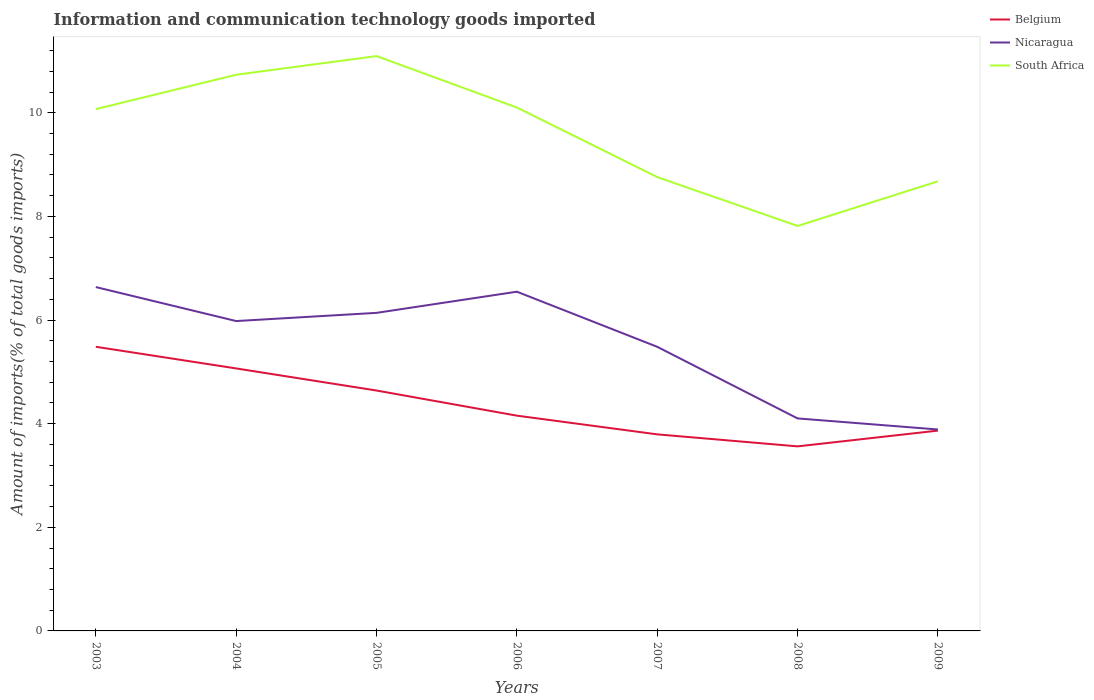How many different coloured lines are there?
Give a very brief answer. 3. Does the line corresponding to South Africa intersect with the line corresponding to Belgium?
Offer a terse response. No. Is the number of lines equal to the number of legend labels?
Keep it short and to the point. Yes. Across all years, what is the maximum amount of goods imported in Belgium?
Offer a very short reply. 3.56. What is the total amount of goods imported in Belgium in the graph?
Your answer should be very brief. 0.49. What is the difference between the highest and the second highest amount of goods imported in Belgium?
Give a very brief answer. 1.92. What is the difference between the highest and the lowest amount of goods imported in Nicaragua?
Make the answer very short. 4. Is the amount of goods imported in Belgium strictly greater than the amount of goods imported in South Africa over the years?
Give a very brief answer. Yes. How many years are there in the graph?
Your answer should be compact. 7. What is the difference between two consecutive major ticks on the Y-axis?
Provide a short and direct response. 2. Does the graph contain any zero values?
Offer a very short reply. No. Where does the legend appear in the graph?
Provide a succinct answer. Top right. How are the legend labels stacked?
Offer a terse response. Vertical. What is the title of the graph?
Keep it short and to the point. Information and communication technology goods imported. What is the label or title of the Y-axis?
Provide a succinct answer. Amount of imports(% of total goods imports). What is the Amount of imports(% of total goods imports) of Belgium in 2003?
Provide a succinct answer. 5.48. What is the Amount of imports(% of total goods imports) of Nicaragua in 2003?
Provide a succinct answer. 6.64. What is the Amount of imports(% of total goods imports) of South Africa in 2003?
Give a very brief answer. 10.07. What is the Amount of imports(% of total goods imports) of Belgium in 2004?
Your answer should be very brief. 5.07. What is the Amount of imports(% of total goods imports) of Nicaragua in 2004?
Provide a short and direct response. 5.98. What is the Amount of imports(% of total goods imports) in South Africa in 2004?
Offer a terse response. 10.73. What is the Amount of imports(% of total goods imports) of Belgium in 2005?
Offer a very short reply. 4.64. What is the Amount of imports(% of total goods imports) in Nicaragua in 2005?
Your answer should be very brief. 6.14. What is the Amount of imports(% of total goods imports) of South Africa in 2005?
Provide a succinct answer. 11.09. What is the Amount of imports(% of total goods imports) of Belgium in 2006?
Give a very brief answer. 4.15. What is the Amount of imports(% of total goods imports) in Nicaragua in 2006?
Ensure brevity in your answer.  6.55. What is the Amount of imports(% of total goods imports) of South Africa in 2006?
Keep it short and to the point. 10.1. What is the Amount of imports(% of total goods imports) of Belgium in 2007?
Ensure brevity in your answer.  3.79. What is the Amount of imports(% of total goods imports) in Nicaragua in 2007?
Give a very brief answer. 5.48. What is the Amount of imports(% of total goods imports) of South Africa in 2007?
Your answer should be compact. 8.76. What is the Amount of imports(% of total goods imports) of Belgium in 2008?
Provide a short and direct response. 3.56. What is the Amount of imports(% of total goods imports) in Nicaragua in 2008?
Keep it short and to the point. 4.1. What is the Amount of imports(% of total goods imports) in South Africa in 2008?
Your answer should be very brief. 7.82. What is the Amount of imports(% of total goods imports) of Belgium in 2009?
Provide a short and direct response. 3.87. What is the Amount of imports(% of total goods imports) in Nicaragua in 2009?
Provide a succinct answer. 3.89. What is the Amount of imports(% of total goods imports) of South Africa in 2009?
Make the answer very short. 8.68. Across all years, what is the maximum Amount of imports(% of total goods imports) in Belgium?
Give a very brief answer. 5.48. Across all years, what is the maximum Amount of imports(% of total goods imports) in Nicaragua?
Offer a terse response. 6.64. Across all years, what is the maximum Amount of imports(% of total goods imports) in South Africa?
Your response must be concise. 11.09. Across all years, what is the minimum Amount of imports(% of total goods imports) in Belgium?
Your response must be concise. 3.56. Across all years, what is the minimum Amount of imports(% of total goods imports) in Nicaragua?
Ensure brevity in your answer.  3.89. Across all years, what is the minimum Amount of imports(% of total goods imports) of South Africa?
Provide a succinct answer. 7.82. What is the total Amount of imports(% of total goods imports) of Belgium in the graph?
Provide a short and direct response. 30.56. What is the total Amount of imports(% of total goods imports) in Nicaragua in the graph?
Offer a terse response. 38.77. What is the total Amount of imports(% of total goods imports) of South Africa in the graph?
Offer a very short reply. 67.25. What is the difference between the Amount of imports(% of total goods imports) in Belgium in 2003 and that in 2004?
Provide a short and direct response. 0.42. What is the difference between the Amount of imports(% of total goods imports) in Nicaragua in 2003 and that in 2004?
Make the answer very short. 0.66. What is the difference between the Amount of imports(% of total goods imports) of South Africa in 2003 and that in 2004?
Provide a succinct answer. -0.66. What is the difference between the Amount of imports(% of total goods imports) in Belgium in 2003 and that in 2005?
Give a very brief answer. 0.84. What is the difference between the Amount of imports(% of total goods imports) in Nicaragua in 2003 and that in 2005?
Your response must be concise. 0.5. What is the difference between the Amount of imports(% of total goods imports) in South Africa in 2003 and that in 2005?
Your answer should be compact. -1.02. What is the difference between the Amount of imports(% of total goods imports) in Belgium in 2003 and that in 2006?
Ensure brevity in your answer.  1.33. What is the difference between the Amount of imports(% of total goods imports) of Nicaragua in 2003 and that in 2006?
Provide a short and direct response. 0.09. What is the difference between the Amount of imports(% of total goods imports) in South Africa in 2003 and that in 2006?
Offer a very short reply. -0.03. What is the difference between the Amount of imports(% of total goods imports) in Belgium in 2003 and that in 2007?
Offer a very short reply. 1.69. What is the difference between the Amount of imports(% of total goods imports) in Nicaragua in 2003 and that in 2007?
Your answer should be very brief. 1.15. What is the difference between the Amount of imports(% of total goods imports) of South Africa in 2003 and that in 2007?
Your response must be concise. 1.31. What is the difference between the Amount of imports(% of total goods imports) in Belgium in 2003 and that in 2008?
Your answer should be compact. 1.92. What is the difference between the Amount of imports(% of total goods imports) in Nicaragua in 2003 and that in 2008?
Your answer should be compact. 2.53. What is the difference between the Amount of imports(% of total goods imports) of South Africa in 2003 and that in 2008?
Your answer should be compact. 2.26. What is the difference between the Amount of imports(% of total goods imports) of Belgium in 2003 and that in 2009?
Ensure brevity in your answer.  1.62. What is the difference between the Amount of imports(% of total goods imports) in Nicaragua in 2003 and that in 2009?
Make the answer very short. 2.75. What is the difference between the Amount of imports(% of total goods imports) in South Africa in 2003 and that in 2009?
Offer a terse response. 1.39. What is the difference between the Amount of imports(% of total goods imports) of Belgium in 2004 and that in 2005?
Your answer should be compact. 0.43. What is the difference between the Amount of imports(% of total goods imports) in Nicaragua in 2004 and that in 2005?
Ensure brevity in your answer.  -0.16. What is the difference between the Amount of imports(% of total goods imports) in South Africa in 2004 and that in 2005?
Provide a succinct answer. -0.36. What is the difference between the Amount of imports(% of total goods imports) of Belgium in 2004 and that in 2006?
Keep it short and to the point. 0.91. What is the difference between the Amount of imports(% of total goods imports) in Nicaragua in 2004 and that in 2006?
Offer a terse response. -0.57. What is the difference between the Amount of imports(% of total goods imports) of South Africa in 2004 and that in 2006?
Give a very brief answer. 0.63. What is the difference between the Amount of imports(% of total goods imports) in Belgium in 2004 and that in 2007?
Keep it short and to the point. 1.27. What is the difference between the Amount of imports(% of total goods imports) of Nicaragua in 2004 and that in 2007?
Offer a terse response. 0.5. What is the difference between the Amount of imports(% of total goods imports) of South Africa in 2004 and that in 2007?
Ensure brevity in your answer.  1.98. What is the difference between the Amount of imports(% of total goods imports) of Belgium in 2004 and that in 2008?
Your answer should be compact. 1.5. What is the difference between the Amount of imports(% of total goods imports) of Nicaragua in 2004 and that in 2008?
Keep it short and to the point. 1.88. What is the difference between the Amount of imports(% of total goods imports) of South Africa in 2004 and that in 2008?
Ensure brevity in your answer.  2.92. What is the difference between the Amount of imports(% of total goods imports) in Belgium in 2004 and that in 2009?
Your answer should be compact. 1.2. What is the difference between the Amount of imports(% of total goods imports) in Nicaragua in 2004 and that in 2009?
Your response must be concise. 2.09. What is the difference between the Amount of imports(% of total goods imports) in South Africa in 2004 and that in 2009?
Offer a very short reply. 2.06. What is the difference between the Amount of imports(% of total goods imports) of Belgium in 2005 and that in 2006?
Provide a succinct answer. 0.48. What is the difference between the Amount of imports(% of total goods imports) in Nicaragua in 2005 and that in 2006?
Make the answer very short. -0.41. What is the difference between the Amount of imports(% of total goods imports) of South Africa in 2005 and that in 2006?
Provide a short and direct response. 0.99. What is the difference between the Amount of imports(% of total goods imports) in Belgium in 2005 and that in 2007?
Your answer should be very brief. 0.85. What is the difference between the Amount of imports(% of total goods imports) of Nicaragua in 2005 and that in 2007?
Keep it short and to the point. 0.66. What is the difference between the Amount of imports(% of total goods imports) of South Africa in 2005 and that in 2007?
Your response must be concise. 2.34. What is the difference between the Amount of imports(% of total goods imports) in Belgium in 2005 and that in 2008?
Your answer should be very brief. 1.08. What is the difference between the Amount of imports(% of total goods imports) in Nicaragua in 2005 and that in 2008?
Give a very brief answer. 2.04. What is the difference between the Amount of imports(% of total goods imports) in South Africa in 2005 and that in 2008?
Your answer should be compact. 3.28. What is the difference between the Amount of imports(% of total goods imports) in Belgium in 2005 and that in 2009?
Provide a short and direct response. 0.77. What is the difference between the Amount of imports(% of total goods imports) in Nicaragua in 2005 and that in 2009?
Give a very brief answer. 2.25. What is the difference between the Amount of imports(% of total goods imports) in South Africa in 2005 and that in 2009?
Keep it short and to the point. 2.42. What is the difference between the Amount of imports(% of total goods imports) of Belgium in 2006 and that in 2007?
Offer a very short reply. 0.36. What is the difference between the Amount of imports(% of total goods imports) of Nicaragua in 2006 and that in 2007?
Offer a very short reply. 1.06. What is the difference between the Amount of imports(% of total goods imports) of South Africa in 2006 and that in 2007?
Keep it short and to the point. 1.34. What is the difference between the Amount of imports(% of total goods imports) in Belgium in 2006 and that in 2008?
Make the answer very short. 0.59. What is the difference between the Amount of imports(% of total goods imports) in Nicaragua in 2006 and that in 2008?
Keep it short and to the point. 2.45. What is the difference between the Amount of imports(% of total goods imports) in South Africa in 2006 and that in 2008?
Give a very brief answer. 2.29. What is the difference between the Amount of imports(% of total goods imports) of Belgium in 2006 and that in 2009?
Give a very brief answer. 0.29. What is the difference between the Amount of imports(% of total goods imports) of Nicaragua in 2006 and that in 2009?
Provide a short and direct response. 2.66. What is the difference between the Amount of imports(% of total goods imports) in South Africa in 2006 and that in 2009?
Provide a short and direct response. 1.42. What is the difference between the Amount of imports(% of total goods imports) of Belgium in 2007 and that in 2008?
Ensure brevity in your answer.  0.23. What is the difference between the Amount of imports(% of total goods imports) of Nicaragua in 2007 and that in 2008?
Offer a very short reply. 1.38. What is the difference between the Amount of imports(% of total goods imports) of South Africa in 2007 and that in 2008?
Give a very brief answer. 0.94. What is the difference between the Amount of imports(% of total goods imports) of Belgium in 2007 and that in 2009?
Provide a succinct answer. -0.07. What is the difference between the Amount of imports(% of total goods imports) of Nicaragua in 2007 and that in 2009?
Give a very brief answer. 1.6. What is the difference between the Amount of imports(% of total goods imports) in South Africa in 2007 and that in 2009?
Give a very brief answer. 0.08. What is the difference between the Amount of imports(% of total goods imports) in Belgium in 2008 and that in 2009?
Offer a very short reply. -0.3. What is the difference between the Amount of imports(% of total goods imports) of Nicaragua in 2008 and that in 2009?
Offer a very short reply. 0.21. What is the difference between the Amount of imports(% of total goods imports) of South Africa in 2008 and that in 2009?
Your response must be concise. -0.86. What is the difference between the Amount of imports(% of total goods imports) of Belgium in 2003 and the Amount of imports(% of total goods imports) of Nicaragua in 2004?
Give a very brief answer. -0.5. What is the difference between the Amount of imports(% of total goods imports) of Belgium in 2003 and the Amount of imports(% of total goods imports) of South Africa in 2004?
Ensure brevity in your answer.  -5.25. What is the difference between the Amount of imports(% of total goods imports) in Nicaragua in 2003 and the Amount of imports(% of total goods imports) in South Africa in 2004?
Your response must be concise. -4.1. What is the difference between the Amount of imports(% of total goods imports) of Belgium in 2003 and the Amount of imports(% of total goods imports) of Nicaragua in 2005?
Offer a terse response. -0.65. What is the difference between the Amount of imports(% of total goods imports) in Belgium in 2003 and the Amount of imports(% of total goods imports) in South Africa in 2005?
Ensure brevity in your answer.  -5.61. What is the difference between the Amount of imports(% of total goods imports) of Nicaragua in 2003 and the Amount of imports(% of total goods imports) of South Africa in 2005?
Keep it short and to the point. -4.46. What is the difference between the Amount of imports(% of total goods imports) in Belgium in 2003 and the Amount of imports(% of total goods imports) in Nicaragua in 2006?
Ensure brevity in your answer.  -1.06. What is the difference between the Amount of imports(% of total goods imports) in Belgium in 2003 and the Amount of imports(% of total goods imports) in South Africa in 2006?
Give a very brief answer. -4.62. What is the difference between the Amount of imports(% of total goods imports) in Nicaragua in 2003 and the Amount of imports(% of total goods imports) in South Africa in 2006?
Keep it short and to the point. -3.46. What is the difference between the Amount of imports(% of total goods imports) in Belgium in 2003 and the Amount of imports(% of total goods imports) in Nicaragua in 2007?
Make the answer very short. 0. What is the difference between the Amount of imports(% of total goods imports) in Belgium in 2003 and the Amount of imports(% of total goods imports) in South Africa in 2007?
Your response must be concise. -3.27. What is the difference between the Amount of imports(% of total goods imports) in Nicaragua in 2003 and the Amount of imports(% of total goods imports) in South Africa in 2007?
Your answer should be very brief. -2.12. What is the difference between the Amount of imports(% of total goods imports) of Belgium in 2003 and the Amount of imports(% of total goods imports) of Nicaragua in 2008?
Provide a succinct answer. 1.38. What is the difference between the Amount of imports(% of total goods imports) of Belgium in 2003 and the Amount of imports(% of total goods imports) of South Africa in 2008?
Keep it short and to the point. -2.33. What is the difference between the Amount of imports(% of total goods imports) in Nicaragua in 2003 and the Amount of imports(% of total goods imports) in South Africa in 2008?
Keep it short and to the point. -1.18. What is the difference between the Amount of imports(% of total goods imports) of Belgium in 2003 and the Amount of imports(% of total goods imports) of Nicaragua in 2009?
Give a very brief answer. 1.6. What is the difference between the Amount of imports(% of total goods imports) of Belgium in 2003 and the Amount of imports(% of total goods imports) of South Africa in 2009?
Your response must be concise. -3.19. What is the difference between the Amount of imports(% of total goods imports) of Nicaragua in 2003 and the Amount of imports(% of total goods imports) of South Africa in 2009?
Provide a succinct answer. -2.04. What is the difference between the Amount of imports(% of total goods imports) of Belgium in 2004 and the Amount of imports(% of total goods imports) of Nicaragua in 2005?
Make the answer very short. -1.07. What is the difference between the Amount of imports(% of total goods imports) of Belgium in 2004 and the Amount of imports(% of total goods imports) of South Africa in 2005?
Your answer should be very brief. -6.03. What is the difference between the Amount of imports(% of total goods imports) of Nicaragua in 2004 and the Amount of imports(% of total goods imports) of South Africa in 2005?
Offer a terse response. -5.11. What is the difference between the Amount of imports(% of total goods imports) in Belgium in 2004 and the Amount of imports(% of total goods imports) in Nicaragua in 2006?
Keep it short and to the point. -1.48. What is the difference between the Amount of imports(% of total goods imports) in Belgium in 2004 and the Amount of imports(% of total goods imports) in South Africa in 2006?
Ensure brevity in your answer.  -5.03. What is the difference between the Amount of imports(% of total goods imports) of Nicaragua in 2004 and the Amount of imports(% of total goods imports) of South Africa in 2006?
Keep it short and to the point. -4.12. What is the difference between the Amount of imports(% of total goods imports) of Belgium in 2004 and the Amount of imports(% of total goods imports) of Nicaragua in 2007?
Give a very brief answer. -0.42. What is the difference between the Amount of imports(% of total goods imports) of Belgium in 2004 and the Amount of imports(% of total goods imports) of South Africa in 2007?
Make the answer very short. -3.69. What is the difference between the Amount of imports(% of total goods imports) in Nicaragua in 2004 and the Amount of imports(% of total goods imports) in South Africa in 2007?
Offer a very short reply. -2.78. What is the difference between the Amount of imports(% of total goods imports) of Belgium in 2004 and the Amount of imports(% of total goods imports) of Nicaragua in 2008?
Your answer should be compact. 0.96. What is the difference between the Amount of imports(% of total goods imports) of Belgium in 2004 and the Amount of imports(% of total goods imports) of South Africa in 2008?
Provide a succinct answer. -2.75. What is the difference between the Amount of imports(% of total goods imports) in Nicaragua in 2004 and the Amount of imports(% of total goods imports) in South Africa in 2008?
Your response must be concise. -1.84. What is the difference between the Amount of imports(% of total goods imports) of Belgium in 2004 and the Amount of imports(% of total goods imports) of Nicaragua in 2009?
Provide a succinct answer. 1.18. What is the difference between the Amount of imports(% of total goods imports) of Belgium in 2004 and the Amount of imports(% of total goods imports) of South Africa in 2009?
Make the answer very short. -3.61. What is the difference between the Amount of imports(% of total goods imports) in Nicaragua in 2004 and the Amount of imports(% of total goods imports) in South Africa in 2009?
Your response must be concise. -2.7. What is the difference between the Amount of imports(% of total goods imports) of Belgium in 2005 and the Amount of imports(% of total goods imports) of Nicaragua in 2006?
Offer a very short reply. -1.91. What is the difference between the Amount of imports(% of total goods imports) in Belgium in 2005 and the Amount of imports(% of total goods imports) in South Africa in 2006?
Keep it short and to the point. -5.46. What is the difference between the Amount of imports(% of total goods imports) of Nicaragua in 2005 and the Amount of imports(% of total goods imports) of South Africa in 2006?
Make the answer very short. -3.96. What is the difference between the Amount of imports(% of total goods imports) of Belgium in 2005 and the Amount of imports(% of total goods imports) of Nicaragua in 2007?
Keep it short and to the point. -0.84. What is the difference between the Amount of imports(% of total goods imports) in Belgium in 2005 and the Amount of imports(% of total goods imports) in South Africa in 2007?
Keep it short and to the point. -4.12. What is the difference between the Amount of imports(% of total goods imports) of Nicaragua in 2005 and the Amount of imports(% of total goods imports) of South Africa in 2007?
Your answer should be compact. -2.62. What is the difference between the Amount of imports(% of total goods imports) in Belgium in 2005 and the Amount of imports(% of total goods imports) in Nicaragua in 2008?
Your answer should be very brief. 0.54. What is the difference between the Amount of imports(% of total goods imports) in Belgium in 2005 and the Amount of imports(% of total goods imports) in South Africa in 2008?
Your response must be concise. -3.18. What is the difference between the Amount of imports(% of total goods imports) in Nicaragua in 2005 and the Amount of imports(% of total goods imports) in South Africa in 2008?
Provide a succinct answer. -1.68. What is the difference between the Amount of imports(% of total goods imports) in Belgium in 2005 and the Amount of imports(% of total goods imports) in Nicaragua in 2009?
Keep it short and to the point. 0.75. What is the difference between the Amount of imports(% of total goods imports) of Belgium in 2005 and the Amount of imports(% of total goods imports) of South Africa in 2009?
Provide a succinct answer. -4.04. What is the difference between the Amount of imports(% of total goods imports) in Nicaragua in 2005 and the Amount of imports(% of total goods imports) in South Africa in 2009?
Your answer should be very brief. -2.54. What is the difference between the Amount of imports(% of total goods imports) in Belgium in 2006 and the Amount of imports(% of total goods imports) in Nicaragua in 2007?
Offer a very short reply. -1.33. What is the difference between the Amount of imports(% of total goods imports) of Belgium in 2006 and the Amount of imports(% of total goods imports) of South Africa in 2007?
Provide a succinct answer. -4.6. What is the difference between the Amount of imports(% of total goods imports) in Nicaragua in 2006 and the Amount of imports(% of total goods imports) in South Africa in 2007?
Keep it short and to the point. -2.21. What is the difference between the Amount of imports(% of total goods imports) in Belgium in 2006 and the Amount of imports(% of total goods imports) in Nicaragua in 2008?
Your answer should be very brief. 0.05. What is the difference between the Amount of imports(% of total goods imports) of Belgium in 2006 and the Amount of imports(% of total goods imports) of South Africa in 2008?
Give a very brief answer. -3.66. What is the difference between the Amount of imports(% of total goods imports) in Nicaragua in 2006 and the Amount of imports(% of total goods imports) in South Africa in 2008?
Your answer should be compact. -1.27. What is the difference between the Amount of imports(% of total goods imports) in Belgium in 2006 and the Amount of imports(% of total goods imports) in Nicaragua in 2009?
Make the answer very short. 0.27. What is the difference between the Amount of imports(% of total goods imports) in Belgium in 2006 and the Amount of imports(% of total goods imports) in South Africa in 2009?
Ensure brevity in your answer.  -4.52. What is the difference between the Amount of imports(% of total goods imports) of Nicaragua in 2006 and the Amount of imports(% of total goods imports) of South Africa in 2009?
Offer a very short reply. -2.13. What is the difference between the Amount of imports(% of total goods imports) in Belgium in 2007 and the Amount of imports(% of total goods imports) in Nicaragua in 2008?
Your answer should be compact. -0.31. What is the difference between the Amount of imports(% of total goods imports) in Belgium in 2007 and the Amount of imports(% of total goods imports) in South Africa in 2008?
Your response must be concise. -4.02. What is the difference between the Amount of imports(% of total goods imports) in Nicaragua in 2007 and the Amount of imports(% of total goods imports) in South Africa in 2008?
Your answer should be very brief. -2.33. What is the difference between the Amount of imports(% of total goods imports) in Belgium in 2007 and the Amount of imports(% of total goods imports) in Nicaragua in 2009?
Ensure brevity in your answer.  -0.09. What is the difference between the Amount of imports(% of total goods imports) of Belgium in 2007 and the Amount of imports(% of total goods imports) of South Africa in 2009?
Your answer should be compact. -4.88. What is the difference between the Amount of imports(% of total goods imports) of Nicaragua in 2007 and the Amount of imports(% of total goods imports) of South Africa in 2009?
Offer a very short reply. -3.19. What is the difference between the Amount of imports(% of total goods imports) in Belgium in 2008 and the Amount of imports(% of total goods imports) in Nicaragua in 2009?
Your answer should be compact. -0.33. What is the difference between the Amount of imports(% of total goods imports) of Belgium in 2008 and the Amount of imports(% of total goods imports) of South Africa in 2009?
Keep it short and to the point. -5.12. What is the difference between the Amount of imports(% of total goods imports) of Nicaragua in 2008 and the Amount of imports(% of total goods imports) of South Africa in 2009?
Offer a terse response. -4.58. What is the average Amount of imports(% of total goods imports) in Belgium per year?
Offer a very short reply. 4.37. What is the average Amount of imports(% of total goods imports) in Nicaragua per year?
Give a very brief answer. 5.54. What is the average Amount of imports(% of total goods imports) in South Africa per year?
Provide a short and direct response. 9.61. In the year 2003, what is the difference between the Amount of imports(% of total goods imports) of Belgium and Amount of imports(% of total goods imports) of Nicaragua?
Offer a very short reply. -1.15. In the year 2003, what is the difference between the Amount of imports(% of total goods imports) in Belgium and Amount of imports(% of total goods imports) in South Africa?
Your response must be concise. -4.59. In the year 2003, what is the difference between the Amount of imports(% of total goods imports) in Nicaragua and Amount of imports(% of total goods imports) in South Africa?
Give a very brief answer. -3.43. In the year 2004, what is the difference between the Amount of imports(% of total goods imports) of Belgium and Amount of imports(% of total goods imports) of Nicaragua?
Keep it short and to the point. -0.91. In the year 2004, what is the difference between the Amount of imports(% of total goods imports) of Belgium and Amount of imports(% of total goods imports) of South Africa?
Keep it short and to the point. -5.67. In the year 2004, what is the difference between the Amount of imports(% of total goods imports) in Nicaragua and Amount of imports(% of total goods imports) in South Africa?
Offer a terse response. -4.75. In the year 2005, what is the difference between the Amount of imports(% of total goods imports) in Belgium and Amount of imports(% of total goods imports) in Nicaragua?
Your answer should be compact. -1.5. In the year 2005, what is the difference between the Amount of imports(% of total goods imports) in Belgium and Amount of imports(% of total goods imports) in South Africa?
Your response must be concise. -6.45. In the year 2005, what is the difference between the Amount of imports(% of total goods imports) in Nicaragua and Amount of imports(% of total goods imports) in South Africa?
Your answer should be compact. -4.96. In the year 2006, what is the difference between the Amount of imports(% of total goods imports) of Belgium and Amount of imports(% of total goods imports) of Nicaragua?
Give a very brief answer. -2.39. In the year 2006, what is the difference between the Amount of imports(% of total goods imports) in Belgium and Amount of imports(% of total goods imports) in South Africa?
Offer a terse response. -5.95. In the year 2006, what is the difference between the Amount of imports(% of total goods imports) of Nicaragua and Amount of imports(% of total goods imports) of South Africa?
Offer a very short reply. -3.55. In the year 2007, what is the difference between the Amount of imports(% of total goods imports) of Belgium and Amount of imports(% of total goods imports) of Nicaragua?
Make the answer very short. -1.69. In the year 2007, what is the difference between the Amount of imports(% of total goods imports) of Belgium and Amount of imports(% of total goods imports) of South Africa?
Your answer should be very brief. -4.96. In the year 2007, what is the difference between the Amount of imports(% of total goods imports) of Nicaragua and Amount of imports(% of total goods imports) of South Africa?
Your response must be concise. -3.27. In the year 2008, what is the difference between the Amount of imports(% of total goods imports) of Belgium and Amount of imports(% of total goods imports) of Nicaragua?
Provide a short and direct response. -0.54. In the year 2008, what is the difference between the Amount of imports(% of total goods imports) of Belgium and Amount of imports(% of total goods imports) of South Africa?
Provide a succinct answer. -4.25. In the year 2008, what is the difference between the Amount of imports(% of total goods imports) in Nicaragua and Amount of imports(% of total goods imports) in South Africa?
Your answer should be compact. -3.71. In the year 2009, what is the difference between the Amount of imports(% of total goods imports) in Belgium and Amount of imports(% of total goods imports) in Nicaragua?
Your answer should be very brief. -0.02. In the year 2009, what is the difference between the Amount of imports(% of total goods imports) in Belgium and Amount of imports(% of total goods imports) in South Africa?
Your response must be concise. -4.81. In the year 2009, what is the difference between the Amount of imports(% of total goods imports) of Nicaragua and Amount of imports(% of total goods imports) of South Africa?
Offer a very short reply. -4.79. What is the ratio of the Amount of imports(% of total goods imports) of Belgium in 2003 to that in 2004?
Offer a very short reply. 1.08. What is the ratio of the Amount of imports(% of total goods imports) in Nicaragua in 2003 to that in 2004?
Your answer should be compact. 1.11. What is the ratio of the Amount of imports(% of total goods imports) of South Africa in 2003 to that in 2004?
Provide a succinct answer. 0.94. What is the ratio of the Amount of imports(% of total goods imports) of Belgium in 2003 to that in 2005?
Provide a succinct answer. 1.18. What is the ratio of the Amount of imports(% of total goods imports) in Nicaragua in 2003 to that in 2005?
Keep it short and to the point. 1.08. What is the ratio of the Amount of imports(% of total goods imports) in South Africa in 2003 to that in 2005?
Your response must be concise. 0.91. What is the ratio of the Amount of imports(% of total goods imports) of Belgium in 2003 to that in 2006?
Offer a very short reply. 1.32. What is the ratio of the Amount of imports(% of total goods imports) in Nicaragua in 2003 to that in 2006?
Offer a terse response. 1.01. What is the ratio of the Amount of imports(% of total goods imports) in South Africa in 2003 to that in 2006?
Offer a very short reply. 1. What is the ratio of the Amount of imports(% of total goods imports) of Belgium in 2003 to that in 2007?
Ensure brevity in your answer.  1.45. What is the ratio of the Amount of imports(% of total goods imports) in Nicaragua in 2003 to that in 2007?
Make the answer very short. 1.21. What is the ratio of the Amount of imports(% of total goods imports) of South Africa in 2003 to that in 2007?
Ensure brevity in your answer.  1.15. What is the ratio of the Amount of imports(% of total goods imports) of Belgium in 2003 to that in 2008?
Provide a short and direct response. 1.54. What is the ratio of the Amount of imports(% of total goods imports) of Nicaragua in 2003 to that in 2008?
Give a very brief answer. 1.62. What is the ratio of the Amount of imports(% of total goods imports) in South Africa in 2003 to that in 2008?
Provide a short and direct response. 1.29. What is the ratio of the Amount of imports(% of total goods imports) of Belgium in 2003 to that in 2009?
Keep it short and to the point. 1.42. What is the ratio of the Amount of imports(% of total goods imports) of Nicaragua in 2003 to that in 2009?
Provide a short and direct response. 1.71. What is the ratio of the Amount of imports(% of total goods imports) in South Africa in 2003 to that in 2009?
Provide a short and direct response. 1.16. What is the ratio of the Amount of imports(% of total goods imports) in Belgium in 2004 to that in 2005?
Provide a succinct answer. 1.09. What is the ratio of the Amount of imports(% of total goods imports) in Nicaragua in 2004 to that in 2005?
Provide a succinct answer. 0.97. What is the ratio of the Amount of imports(% of total goods imports) in South Africa in 2004 to that in 2005?
Give a very brief answer. 0.97. What is the ratio of the Amount of imports(% of total goods imports) in Belgium in 2004 to that in 2006?
Provide a short and direct response. 1.22. What is the ratio of the Amount of imports(% of total goods imports) of Nicaragua in 2004 to that in 2006?
Your answer should be very brief. 0.91. What is the ratio of the Amount of imports(% of total goods imports) in South Africa in 2004 to that in 2006?
Provide a succinct answer. 1.06. What is the ratio of the Amount of imports(% of total goods imports) of Belgium in 2004 to that in 2007?
Provide a succinct answer. 1.34. What is the ratio of the Amount of imports(% of total goods imports) in Nicaragua in 2004 to that in 2007?
Offer a terse response. 1.09. What is the ratio of the Amount of imports(% of total goods imports) in South Africa in 2004 to that in 2007?
Your answer should be compact. 1.23. What is the ratio of the Amount of imports(% of total goods imports) in Belgium in 2004 to that in 2008?
Provide a short and direct response. 1.42. What is the ratio of the Amount of imports(% of total goods imports) of Nicaragua in 2004 to that in 2008?
Offer a terse response. 1.46. What is the ratio of the Amount of imports(% of total goods imports) of South Africa in 2004 to that in 2008?
Offer a terse response. 1.37. What is the ratio of the Amount of imports(% of total goods imports) of Belgium in 2004 to that in 2009?
Make the answer very short. 1.31. What is the ratio of the Amount of imports(% of total goods imports) in Nicaragua in 2004 to that in 2009?
Provide a succinct answer. 1.54. What is the ratio of the Amount of imports(% of total goods imports) in South Africa in 2004 to that in 2009?
Provide a succinct answer. 1.24. What is the ratio of the Amount of imports(% of total goods imports) in Belgium in 2005 to that in 2006?
Offer a terse response. 1.12. What is the ratio of the Amount of imports(% of total goods imports) in Nicaragua in 2005 to that in 2006?
Your response must be concise. 0.94. What is the ratio of the Amount of imports(% of total goods imports) in South Africa in 2005 to that in 2006?
Your answer should be compact. 1.1. What is the ratio of the Amount of imports(% of total goods imports) in Belgium in 2005 to that in 2007?
Ensure brevity in your answer.  1.22. What is the ratio of the Amount of imports(% of total goods imports) of Nicaragua in 2005 to that in 2007?
Offer a terse response. 1.12. What is the ratio of the Amount of imports(% of total goods imports) in South Africa in 2005 to that in 2007?
Give a very brief answer. 1.27. What is the ratio of the Amount of imports(% of total goods imports) of Belgium in 2005 to that in 2008?
Give a very brief answer. 1.3. What is the ratio of the Amount of imports(% of total goods imports) in Nicaragua in 2005 to that in 2008?
Offer a terse response. 1.5. What is the ratio of the Amount of imports(% of total goods imports) of South Africa in 2005 to that in 2008?
Your answer should be very brief. 1.42. What is the ratio of the Amount of imports(% of total goods imports) of Belgium in 2005 to that in 2009?
Give a very brief answer. 1.2. What is the ratio of the Amount of imports(% of total goods imports) in Nicaragua in 2005 to that in 2009?
Give a very brief answer. 1.58. What is the ratio of the Amount of imports(% of total goods imports) in South Africa in 2005 to that in 2009?
Ensure brevity in your answer.  1.28. What is the ratio of the Amount of imports(% of total goods imports) in Belgium in 2006 to that in 2007?
Provide a succinct answer. 1.1. What is the ratio of the Amount of imports(% of total goods imports) in Nicaragua in 2006 to that in 2007?
Provide a short and direct response. 1.19. What is the ratio of the Amount of imports(% of total goods imports) of South Africa in 2006 to that in 2007?
Offer a very short reply. 1.15. What is the ratio of the Amount of imports(% of total goods imports) of Belgium in 2006 to that in 2008?
Your response must be concise. 1.17. What is the ratio of the Amount of imports(% of total goods imports) of Nicaragua in 2006 to that in 2008?
Your answer should be very brief. 1.6. What is the ratio of the Amount of imports(% of total goods imports) of South Africa in 2006 to that in 2008?
Ensure brevity in your answer.  1.29. What is the ratio of the Amount of imports(% of total goods imports) in Belgium in 2006 to that in 2009?
Your answer should be compact. 1.07. What is the ratio of the Amount of imports(% of total goods imports) in Nicaragua in 2006 to that in 2009?
Give a very brief answer. 1.68. What is the ratio of the Amount of imports(% of total goods imports) in South Africa in 2006 to that in 2009?
Your answer should be compact. 1.16. What is the ratio of the Amount of imports(% of total goods imports) in Belgium in 2007 to that in 2008?
Ensure brevity in your answer.  1.07. What is the ratio of the Amount of imports(% of total goods imports) of Nicaragua in 2007 to that in 2008?
Ensure brevity in your answer.  1.34. What is the ratio of the Amount of imports(% of total goods imports) of South Africa in 2007 to that in 2008?
Your answer should be compact. 1.12. What is the ratio of the Amount of imports(% of total goods imports) in Belgium in 2007 to that in 2009?
Your answer should be very brief. 0.98. What is the ratio of the Amount of imports(% of total goods imports) in Nicaragua in 2007 to that in 2009?
Make the answer very short. 1.41. What is the ratio of the Amount of imports(% of total goods imports) of South Africa in 2007 to that in 2009?
Provide a succinct answer. 1.01. What is the ratio of the Amount of imports(% of total goods imports) of Belgium in 2008 to that in 2009?
Offer a terse response. 0.92. What is the ratio of the Amount of imports(% of total goods imports) in Nicaragua in 2008 to that in 2009?
Your answer should be very brief. 1.05. What is the ratio of the Amount of imports(% of total goods imports) in South Africa in 2008 to that in 2009?
Your answer should be very brief. 0.9. What is the difference between the highest and the second highest Amount of imports(% of total goods imports) in Belgium?
Your answer should be very brief. 0.42. What is the difference between the highest and the second highest Amount of imports(% of total goods imports) of Nicaragua?
Keep it short and to the point. 0.09. What is the difference between the highest and the second highest Amount of imports(% of total goods imports) of South Africa?
Provide a succinct answer. 0.36. What is the difference between the highest and the lowest Amount of imports(% of total goods imports) in Belgium?
Offer a terse response. 1.92. What is the difference between the highest and the lowest Amount of imports(% of total goods imports) of Nicaragua?
Your answer should be very brief. 2.75. What is the difference between the highest and the lowest Amount of imports(% of total goods imports) of South Africa?
Give a very brief answer. 3.28. 